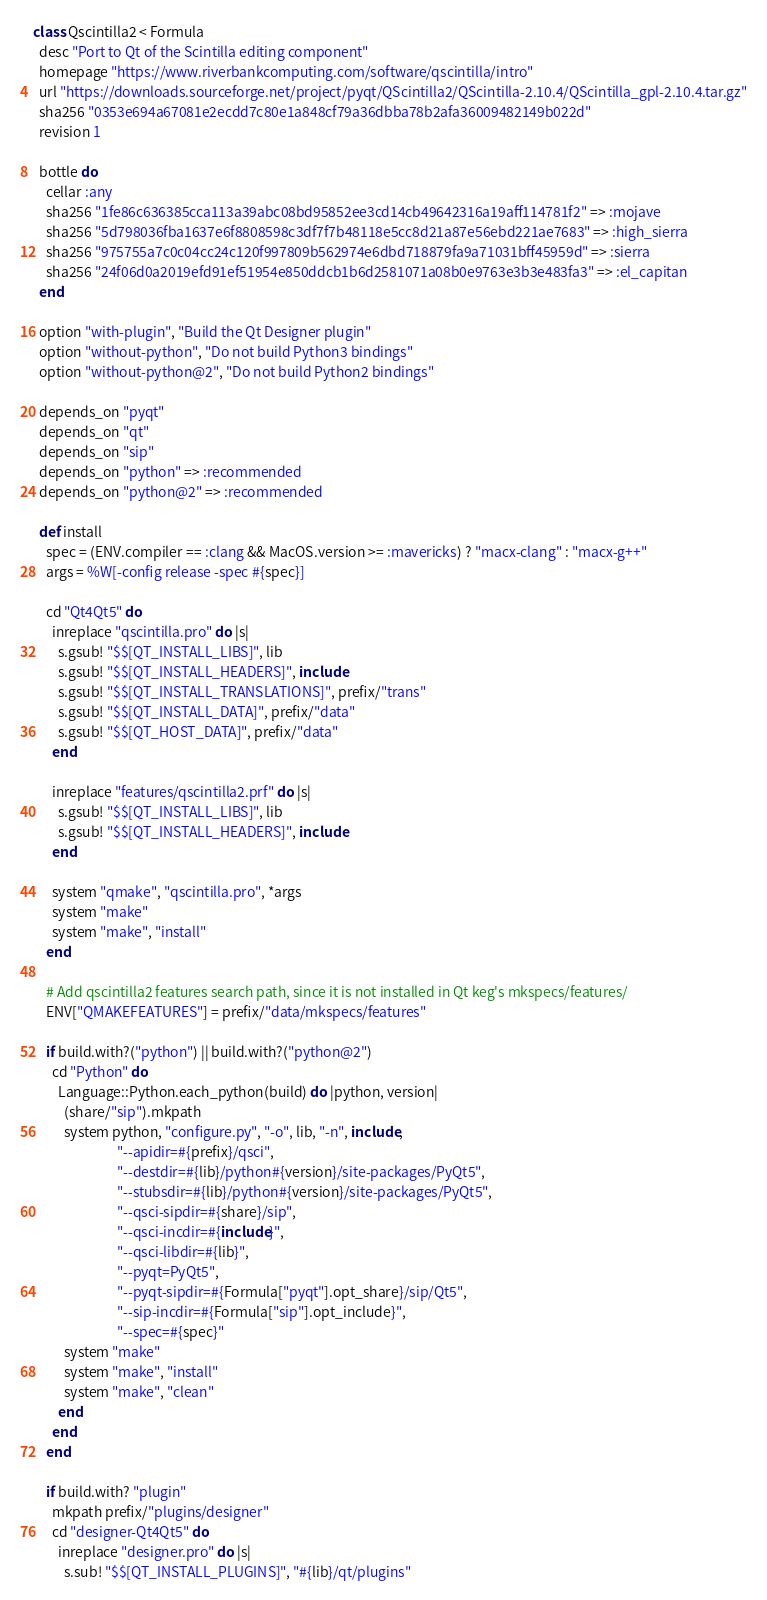Convert code to text. <code><loc_0><loc_0><loc_500><loc_500><_Ruby_>class Qscintilla2 < Formula
  desc "Port to Qt of the Scintilla editing component"
  homepage "https://www.riverbankcomputing.com/software/qscintilla/intro"
  url "https://downloads.sourceforge.net/project/pyqt/QScintilla2/QScintilla-2.10.4/QScintilla_gpl-2.10.4.tar.gz"
  sha256 "0353e694a67081e2ecdd7c80e1a848cf79a36dbba78b2afa36009482149b022d"
  revision 1

  bottle do
    cellar :any
    sha256 "1fe86c636385cca113a39abc08bd95852ee3cd14cb49642316a19aff114781f2" => :mojave
    sha256 "5d798036fba1637e6f8808598c3df7f7b48118e5cc8d21a87e56ebd221ae7683" => :high_sierra
    sha256 "975755a7c0c04cc24c120f997809b562974e6dbd718879fa9a71031bff45959d" => :sierra
    sha256 "24f06d0a2019efd91ef51954e850ddcb1b6d2581071a08b0e9763e3b3e483fa3" => :el_capitan
  end

  option "with-plugin", "Build the Qt Designer plugin"
  option "without-python", "Do not build Python3 bindings"
  option "without-python@2", "Do not build Python2 bindings"

  depends_on "pyqt"
  depends_on "qt"
  depends_on "sip"
  depends_on "python" => :recommended
  depends_on "python@2" => :recommended

  def install
    spec = (ENV.compiler == :clang && MacOS.version >= :mavericks) ? "macx-clang" : "macx-g++"
    args = %W[-config release -spec #{spec}]

    cd "Qt4Qt5" do
      inreplace "qscintilla.pro" do |s|
        s.gsub! "$$[QT_INSTALL_LIBS]", lib
        s.gsub! "$$[QT_INSTALL_HEADERS]", include
        s.gsub! "$$[QT_INSTALL_TRANSLATIONS]", prefix/"trans"
        s.gsub! "$$[QT_INSTALL_DATA]", prefix/"data"
        s.gsub! "$$[QT_HOST_DATA]", prefix/"data"
      end

      inreplace "features/qscintilla2.prf" do |s|
        s.gsub! "$$[QT_INSTALL_LIBS]", lib
        s.gsub! "$$[QT_INSTALL_HEADERS]", include
      end

      system "qmake", "qscintilla.pro", *args
      system "make"
      system "make", "install"
    end

    # Add qscintilla2 features search path, since it is not installed in Qt keg's mkspecs/features/
    ENV["QMAKEFEATURES"] = prefix/"data/mkspecs/features"

    if build.with?("python") || build.with?("python@2")
      cd "Python" do
        Language::Python.each_python(build) do |python, version|
          (share/"sip").mkpath
          system python, "configure.py", "-o", lib, "-n", include,
                           "--apidir=#{prefix}/qsci",
                           "--destdir=#{lib}/python#{version}/site-packages/PyQt5",
                           "--stubsdir=#{lib}/python#{version}/site-packages/PyQt5",
                           "--qsci-sipdir=#{share}/sip",
                           "--qsci-incdir=#{include}",
                           "--qsci-libdir=#{lib}",
                           "--pyqt=PyQt5",
                           "--pyqt-sipdir=#{Formula["pyqt"].opt_share}/sip/Qt5",
                           "--sip-incdir=#{Formula["sip"].opt_include}",
                           "--spec=#{spec}"
          system "make"
          system "make", "install"
          system "make", "clean"
        end
      end
    end

    if build.with? "plugin"
      mkpath prefix/"plugins/designer"
      cd "designer-Qt4Qt5" do
        inreplace "designer.pro" do |s|
          s.sub! "$$[QT_INSTALL_PLUGINS]", "#{lib}/qt/plugins"</code> 